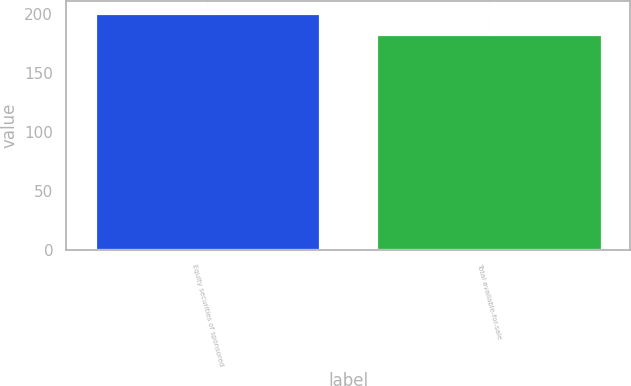<chart> <loc_0><loc_0><loc_500><loc_500><bar_chart><fcel>Equity securities of sponsored<fcel>Total available-for-sale<nl><fcel>201<fcel>183<nl></chart> 